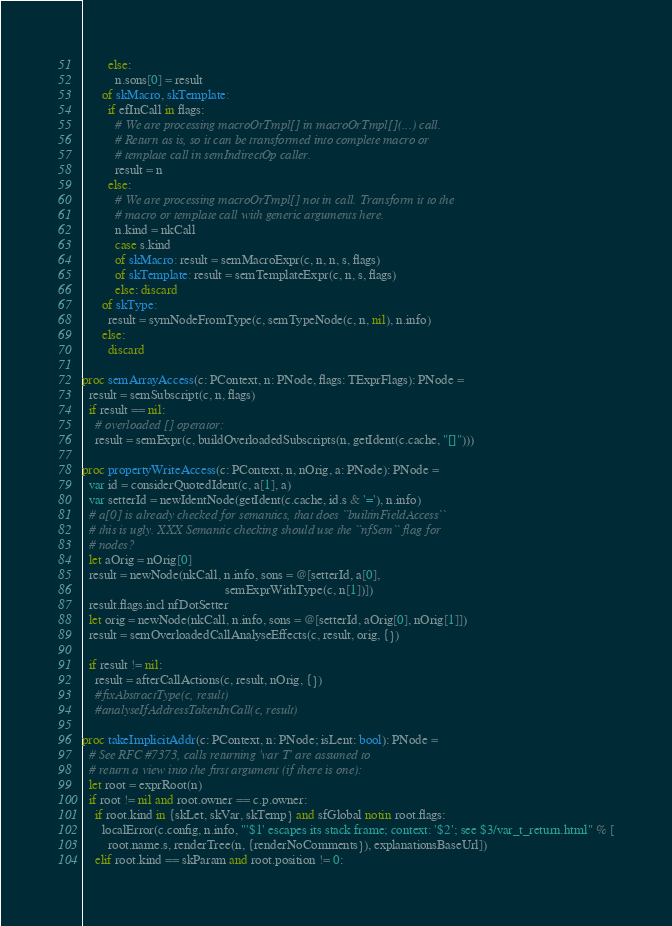<code> <loc_0><loc_0><loc_500><loc_500><_Nim_>        else:
          n.sons[0] = result
      of skMacro, skTemplate:
        if efInCall in flags:
          # We are processing macroOrTmpl[] in macroOrTmpl[](...) call.
          # Return as is, so it can be transformed into complete macro or
          # template call in semIndirectOp caller.
          result = n
        else:
          # We are processing macroOrTmpl[] not in call. Transform it to the
          # macro or template call with generic arguments here.
          n.kind = nkCall
          case s.kind
          of skMacro: result = semMacroExpr(c, n, n, s, flags)
          of skTemplate: result = semTemplateExpr(c, n, s, flags)
          else: discard
      of skType:
        result = symNodeFromType(c, semTypeNode(c, n, nil), n.info)
      else:
        discard

proc semArrayAccess(c: PContext, n: PNode, flags: TExprFlags): PNode =
  result = semSubscript(c, n, flags)
  if result == nil:
    # overloaded [] operator:
    result = semExpr(c, buildOverloadedSubscripts(n, getIdent(c.cache, "[]")))

proc propertyWriteAccess(c: PContext, n, nOrig, a: PNode): PNode =
  var id = considerQuotedIdent(c, a[1], a)
  var setterId = newIdentNode(getIdent(c.cache, id.s & '='), n.info)
  # a[0] is already checked for semantics, that does ``builtinFieldAccess``
  # this is ugly. XXX Semantic checking should use the ``nfSem`` flag for
  # nodes?
  let aOrig = nOrig[0]
  result = newNode(nkCall, n.info, sons = @[setterId, a[0],
                                            semExprWithType(c, n[1])])
  result.flags.incl nfDotSetter
  let orig = newNode(nkCall, n.info, sons = @[setterId, aOrig[0], nOrig[1]])
  result = semOverloadedCallAnalyseEffects(c, result, orig, {})

  if result != nil:
    result = afterCallActions(c, result, nOrig, {})
    #fixAbstractType(c, result)
    #analyseIfAddressTakenInCall(c, result)

proc takeImplicitAddr(c: PContext, n: PNode; isLent: bool): PNode =
  # See RFC #7373, calls returning 'var T' are assumed to
  # return a view into the first argument (if there is one):
  let root = exprRoot(n)
  if root != nil and root.owner == c.p.owner:
    if root.kind in {skLet, skVar, skTemp} and sfGlobal notin root.flags:
      localError(c.config, n.info, "'$1' escapes its stack frame; context: '$2'; see $3/var_t_return.html" % [
        root.name.s, renderTree(n, {renderNoComments}), explanationsBaseUrl])
    elif root.kind == skParam and root.position != 0:</code> 